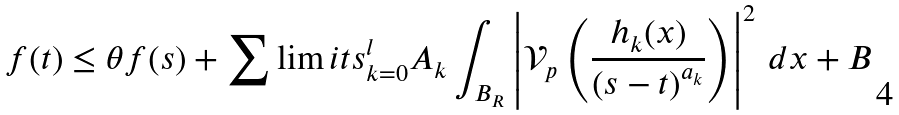<formula> <loc_0><loc_0><loc_500><loc_500>f ( t ) \leq \theta f ( s ) + \sum \lim i t s _ { k = 0 } ^ { l } A _ { k } \int _ { B _ { R } } \left | { \mathcal { V } } _ { p } \left ( \frac { h _ { k } ( x ) } { \left ( s - t \right ) ^ { a _ { k } } } \right ) \right | ^ { 2 } \, d x + B</formula> 